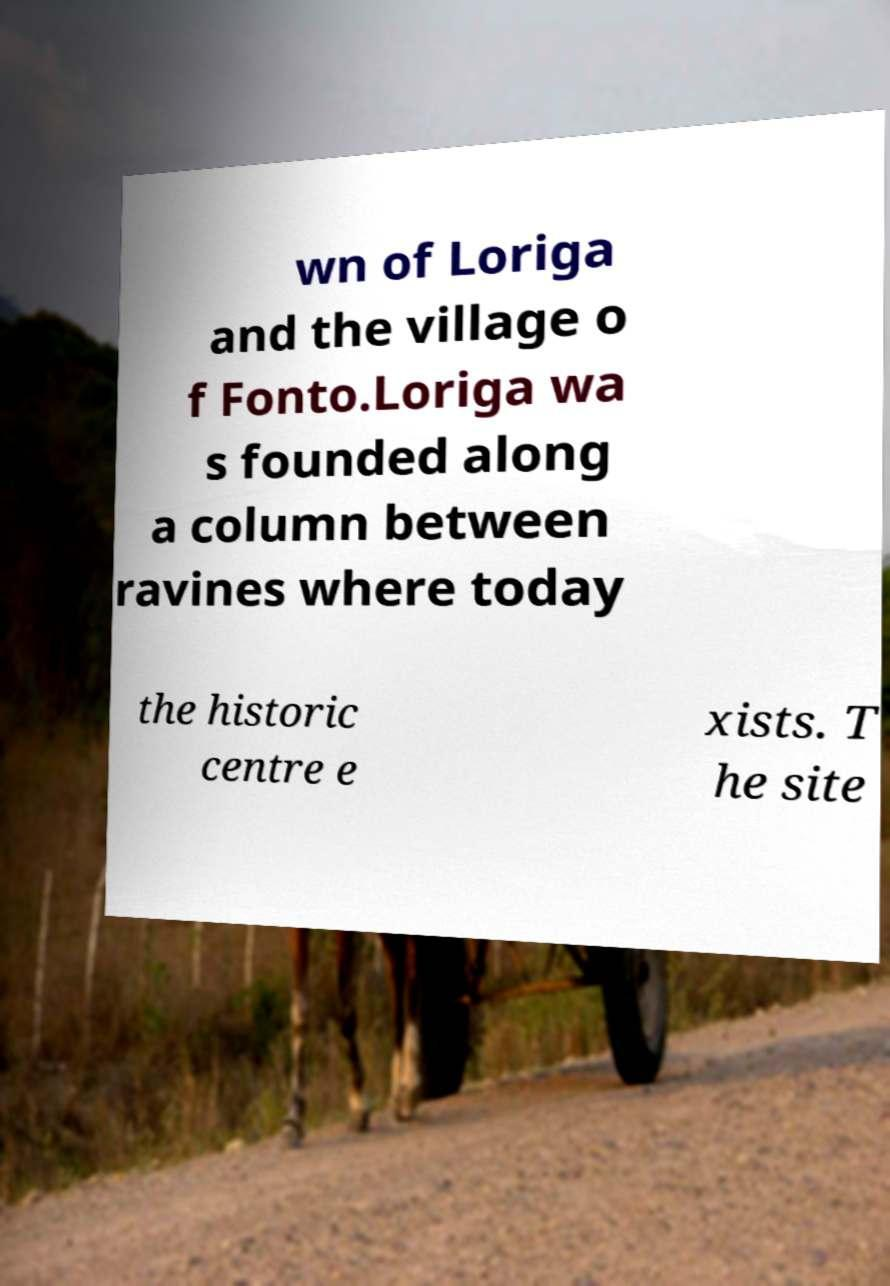There's text embedded in this image that I need extracted. Can you transcribe it verbatim? wn of Loriga and the village o f Fonto.Loriga wa s founded along a column between ravines where today the historic centre e xists. T he site 